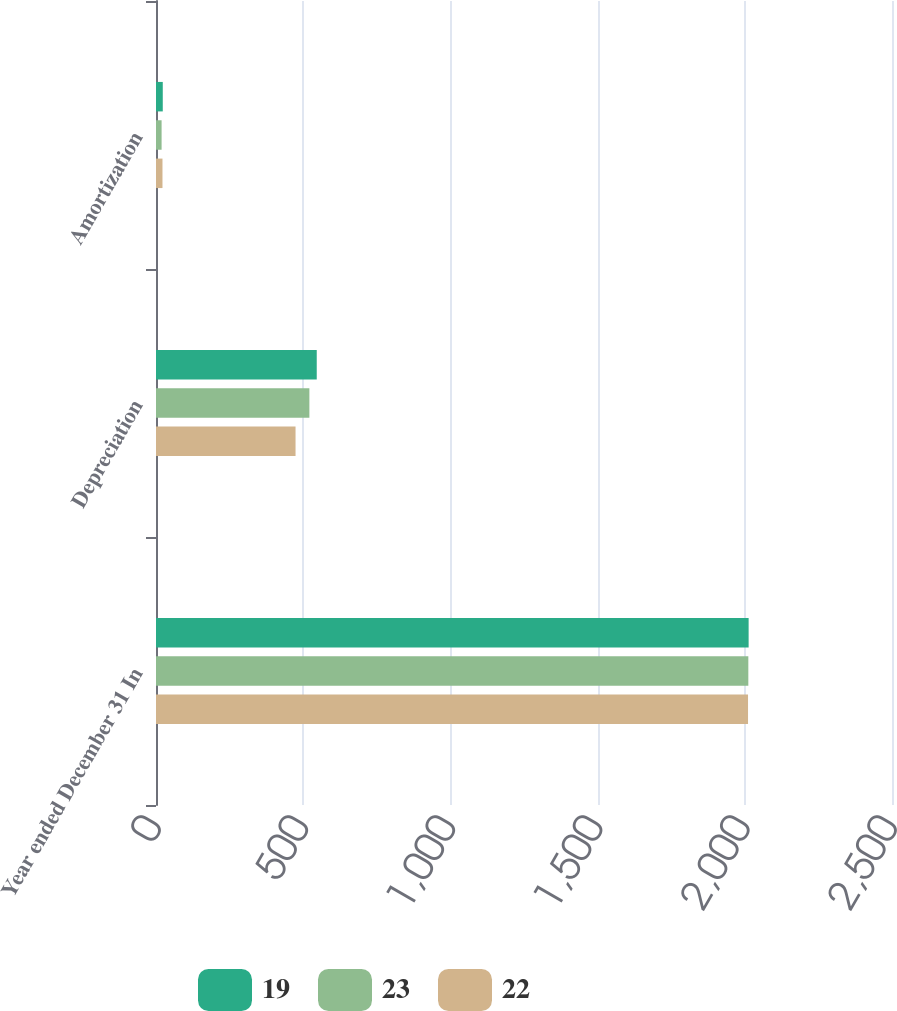Convert chart. <chart><loc_0><loc_0><loc_500><loc_500><stacked_bar_chart><ecel><fcel>Year ended December 31 In<fcel>Depreciation<fcel>Amortization<nl><fcel>19<fcel>2013<fcel>546<fcel>23<nl><fcel>23<fcel>2012<fcel>521<fcel>19<nl><fcel>22<fcel>2011<fcel>474<fcel>22<nl></chart> 